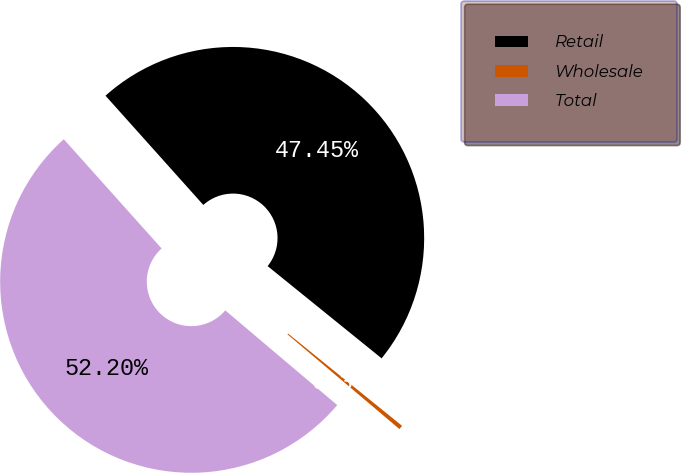Convert chart to OTSL. <chart><loc_0><loc_0><loc_500><loc_500><pie_chart><fcel>Retail<fcel>Wholesale<fcel>Total<nl><fcel>47.45%<fcel>0.35%<fcel>52.2%<nl></chart> 